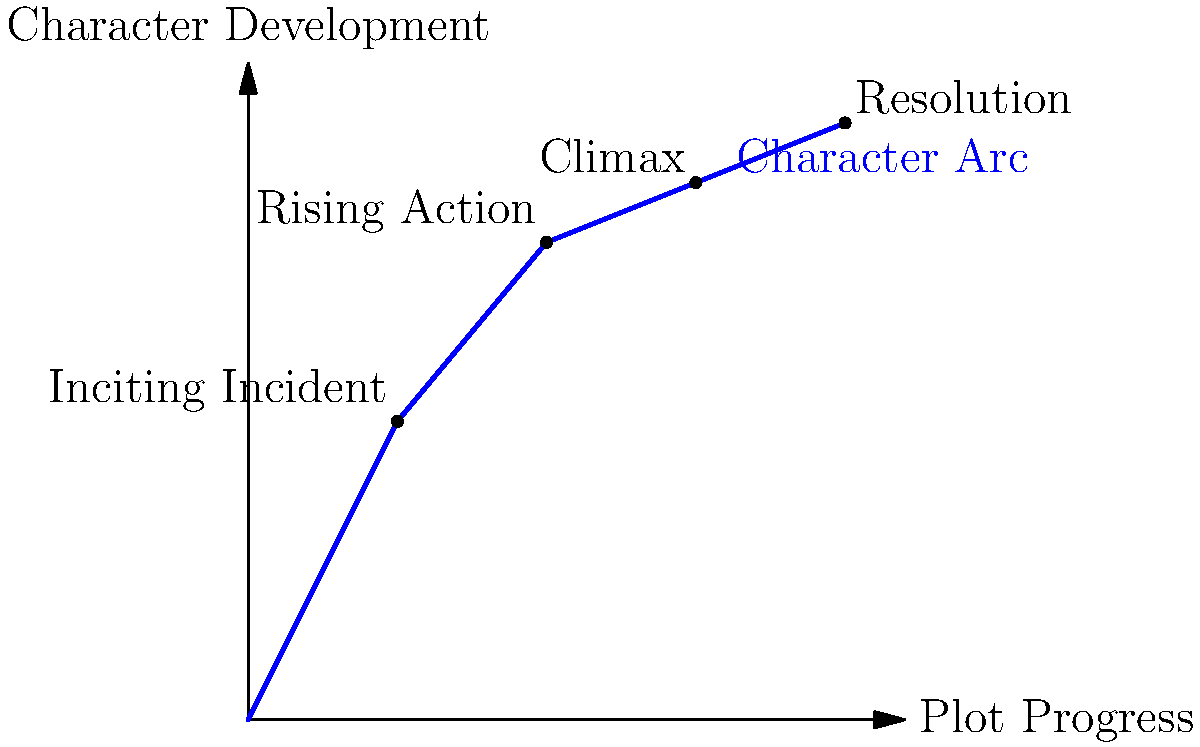In the context of narrative writing, analyze the plot diagram provided. How does this visual representation relate to character development throughout a story, and what might the peak of the curve signify in terms of a protagonist's journey? To understand this plot diagram in relation to character development:

1. Recognize the axes:
   - X-axis represents plot progress (time/events in the story)
   - Y-axis represents character development (growth, change)

2. Identify key points on the curve:
   - Starting point (0,0): Beginning of the story, initial character state
   - Inciting Incident: Event that sets the story in motion
   - Rising Action: Character faces challenges and grows
   - Climax: Highest point on the curve
   - Resolution: Final character state after the main conflict

3. Interpret the curve:
   - Upward slope indicates character growth and development
   - Steeper sections suggest more rapid change
   - Flatter sections imply slower development or stability

4. Analyze the peak (Climax):
   - Represents the turning point in the character's journey
   - Often coincides with the most significant challenge or decision
   - Character has developed the most by this point

5. Consider the Resolution:
   - Shows the character's final state after overcoming challenges
   - Demonstrates overall growth from beginning to end

6. Reflect on the smooth curve:
   - Suggests gradual, continuous character development
   - In reality, character growth might be more irregular

This diagram visualizes how a character evolves throughout a story, with the peak representing the moment of greatest change or realization in their journey.
Answer: The plot diagram visualizes character development over time, with the peak (climax) representing the protagonist's moment of greatest change or realization. 